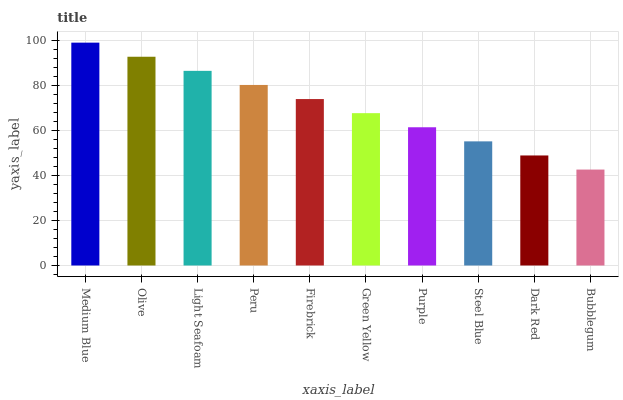Is Olive the minimum?
Answer yes or no. No. Is Olive the maximum?
Answer yes or no. No. Is Medium Blue greater than Olive?
Answer yes or no. Yes. Is Olive less than Medium Blue?
Answer yes or no. Yes. Is Olive greater than Medium Blue?
Answer yes or no. No. Is Medium Blue less than Olive?
Answer yes or no. No. Is Firebrick the high median?
Answer yes or no. Yes. Is Green Yellow the low median?
Answer yes or no. Yes. Is Purple the high median?
Answer yes or no. No. Is Light Seafoam the low median?
Answer yes or no. No. 